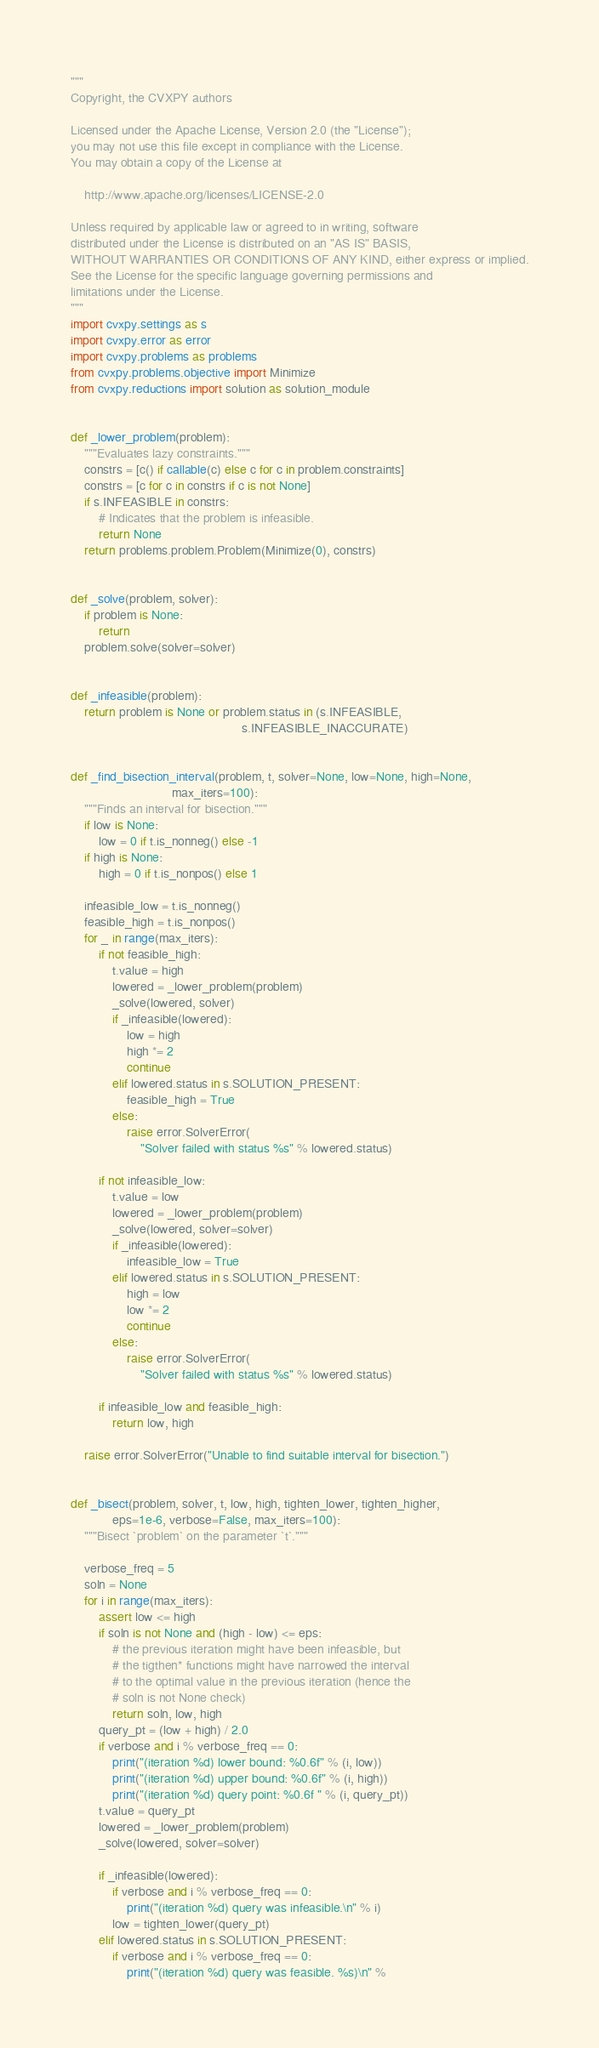Convert code to text. <code><loc_0><loc_0><loc_500><loc_500><_Python_>"""
Copyright, the CVXPY authors

Licensed under the Apache License, Version 2.0 (the "License");
you may not use this file except in compliance with the License.
You may obtain a copy of the License at

    http://www.apache.org/licenses/LICENSE-2.0

Unless required by applicable law or agreed to in writing, software
distributed under the License is distributed on an "AS IS" BASIS,
WITHOUT WARRANTIES OR CONDITIONS OF ANY KIND, either express or implied.
See the License for the specific language governing permissions and
limitations under the License.
"""
import cvxpy.settings as s
import cvxpy.error as error
import cvxpy.problems as problems
from cvxpy.problems.objective import Minimize
from cvxpy.reductions import solution as solution_module


def _lower_problem(problem):
    """Evaluates lazy constraints."""
    constrs = [c() if callable(c) else c for c in problem.constraints]
    constrs = [c for c in constrs if c is not None]
    if s.INFEASIBLE in constrs:
        # Indicates that the problem is infeasible.
        return None
    return problems.problem.Problem(Minimize(0), constrs)


def _solve(problem, solver):
    if problem is None:
        return
    problem.solve(solver=solver)


def _infeasible(problem):
    return problem is None or problem.status in (s.INFEASIBLE,
                                                 s.INFEASIBLE_INACCURATE)


def _find_bisection_interval(problem, t, solver=None, low=None, high=None,
                             max_iters=100):
    """Finds an interval for bisection."""
    if low is None:
        low = 0 if t.is_nonneg() else -1
    if high is None:
        high = 0 if t.is_nonpos() else 1

    infeasible_low = t.is_nonneg()
    feasible_high = t.is_nonpos()
    for _ in range(max_iters):
        if not feasible_high:
            t.value = high
            lowered = _lower_problem(problem)
            _solve(lowered, solver)
            if _infeasible(lowered):
                low = high
                high *= 2
                continue
            elif lowered.status in s.SOLUTION_PRESENT:
                feasible_high = True
            else:
                raise error.SolverError(
                    "Solver failed with status %s" % lowered.status)

        if not infeasible_low:
            t.value = low
            lowered = _lower_problem(problem)
            _solve(lowered, solver=solver)
            if _infeasible(lowered):
                infeasible_low = True
            elif lowered.status in s.SOLUTION_PRESENT:
                high = low
                low *= 2
                continue
            else:
                raise error.SolverError(
                    "Solver failed with status %s" % lowered.status)

        if infeasible_low and feasible_high:
            return low, high

    raise error.SolverError("Unable to find suitable interval for bisection.")


def _bisect(problem, solver, t, low, high, tighten_lower, tighten_higher,
            eps=1e-6, verbose=False, max_iters=100):
    """Bisect `problem` on the parameter `t`."""

    verbose_freq = 5
    soln = None
    for i in range(max_iters):
        assert low <= high
        if soln is not None and (high - low) <= eps:
            # the previous iteration might have been infeasible, but
            # the tigthen* functions might have narrowed the interval
            # to the optimal value in the previous iteration (hence the
            # soln is not None check)
            return soln, low, high
        query_pt = (low + high) / 2.0
        if verbose and i % verbose_freq == 0:
            print("(iteration %d) lower bound: %0.6f" % (i, low))
            print("(iteration %d) upper bound: %0.6f" % (i, high))
            print("(iteration %d) query point: %0.6f " % (i, query_pt))
        t.value = query_pt
        lowered = _lower_problem(problem)
        _solve(lowered, solver=solver)

        if _infeasible(lowered):
            if verbose and i % verbose_freq == 0:
                print("(iteration %d) query was infeasible.\n" % i)
            low = tighten_lower(query_pt)
        elif lowered.status in s.SOLUTION_PRESENT:
            if verbose and i % verbose_freq == 0:
                print("(iteration %d) query was feasible. %s)\n" %</code> 